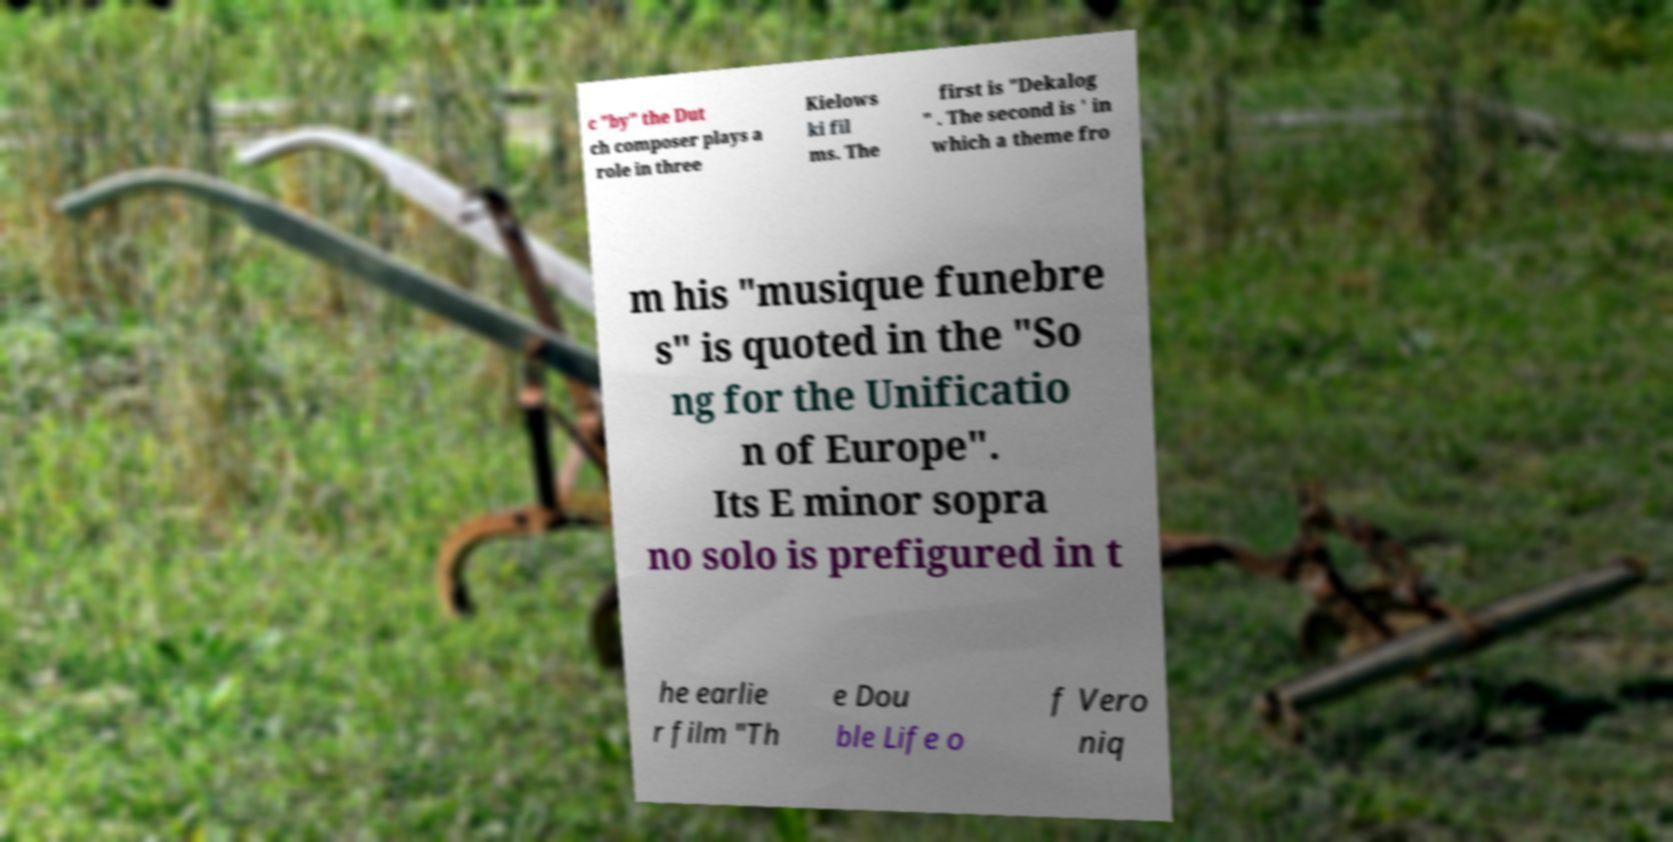Could you extract and type out the text from this image? c "by" the Dut ch composer plays a role in three Kielows ki fil ms. The first is "Dekalog " . The second is ' in which a theme fro m his "musique funebre s" is quoted in the "So ng for the Unificatio n of Europe". Its E minor sopra no solo is prefigured in t he earlie r film "Th e Dou ble Life o f Vero niq 